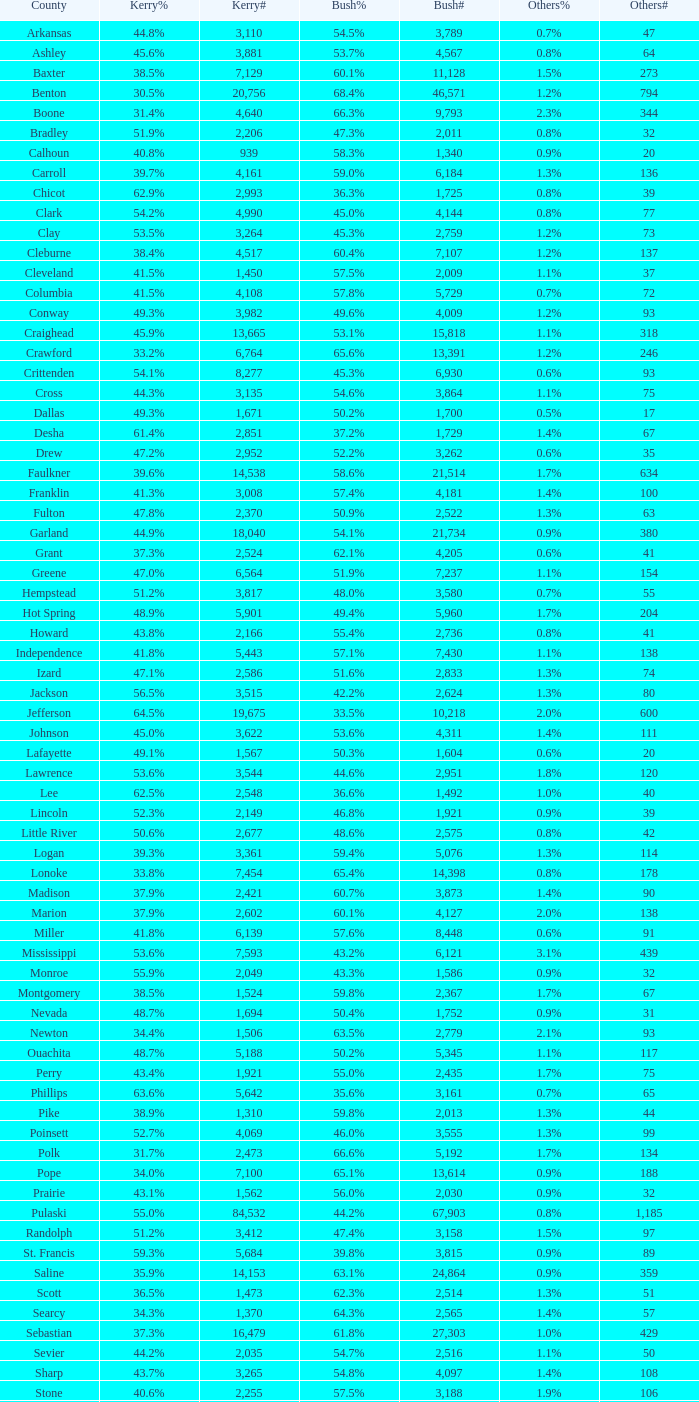What is the highest Bush#, when Others% is "1.7%", when Others# is less than 75, and when Kerry# is greater than 1,524? None. 